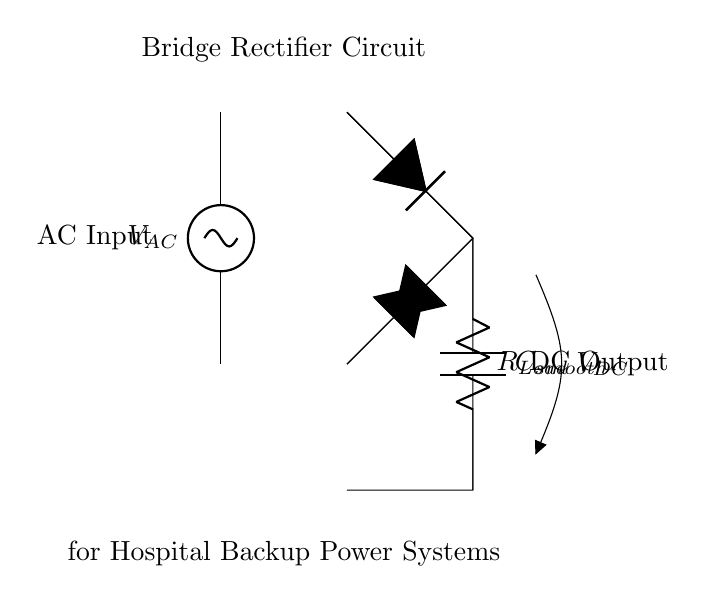What is the type of current supplied to the circuit? The current supplied to the circuit is alternating current, as indicated by the source labelled V_AC at the top of the diagram.
Answer: Alternating current What is the role of the smoothing capacitor in this circuit? The smoothing capacitor is used to reduce voltage ripple and stabilize the output DC voltage. It charges and discharges to smooth the pulsed output from the rectifier.
Answer: Reduce voltage ripple How many diodes are used in the bridge rectifier configuration? The bridge rectifier contains four diodes, as represented in the circuit schematic which shows each diode connected in a bridge formation.
Answer: Four diodes What happens to the output current when AC input is applied to the circuit? The output current becomes direct current after rectification. The AC input is converted to DC by the bridge rectifier, resulting in an output that flows in one direction.
Answer: Direct current What component is represented as R_Load in this circuit? R_Load represents a load resistor, which is connected in the output path of the circuit and absorbs the output current for the load.
Answer: Load resistor 